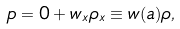<formula> <loc_0><loc_0><loc_500><loc_500>p = 0 + w _ { x } \rho _ { x } \equiv w ( a ) \rho ,</formula> 